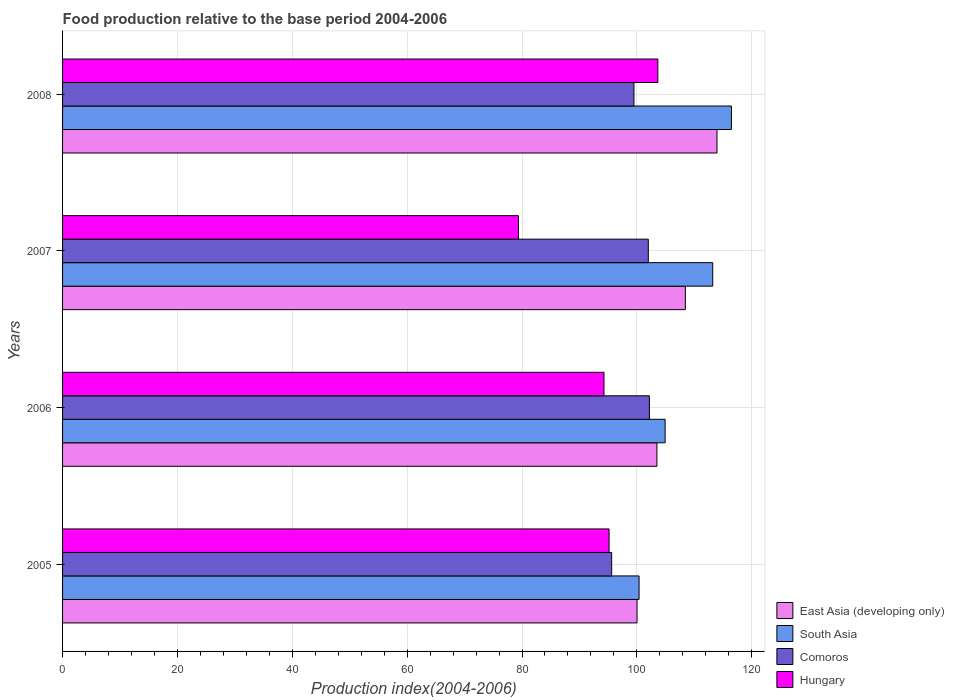How many different coloured bars are there?
Your response must be concise. 4. How many groups of bars are there?
Your response must be concise. 4. Are the number of bars on each tick of the Y-axis equal?
Ensure brevity in your answer.  Yes. How many bars are there on the 4th tick from the top?
Keep it short and to the point. 4. How many bars are there on the 4th tick from the bottom?
Your answer should be compact. 4. What is the food production index in Comoros in 2007?
Your response must be concise. 101.99. Across all years, what is the maximum food production index in East Asia (developing only)?
Offer a terse response. 113.95. Across all years, what is the minimum food production index in East Asia (developing only)?
Your answer should be very brief. 100.03. In which year was the food production index in South Asia maximum?
Ensure brevity in your answer.  2008. In which year was the food production index in Comoros minimum?
Offer a very short reply. 2005. What is the total food production index in South Asia in the graph?
Keep it short and to the point. 434.97. What is the difference between the food production index in Hungary in 2007 and that in 2008?
Ensure brevity in your answer.  -24.27. What is the difference between the food production index in Hungary in 2006 and the food production index in East Asia (developing only) in 2008?
Your response must be concise. -19.68. What is the average food production index in South Asia per year?
Offer a terse response. 108.74. In the year 2006, what is the difference between the food production index in Hungary and food production index in East Asia (developing only)?
Offer a terse response. -9.22. What is the ratio of the food production index in South Asia in 2006 to that in 2008?
Give a very brief answer. 0.9. What is the difference between the highest and the second highest food production index in Hungary?
Ensure brevity in your answer.  8.49. What is the difference between the highest and the lowest food production index in Comoros?
Provide a succinct answer. 6.57. What does the 1st bar from the top in 2008 represents?
Offer a terse response. Hungary. What does the 4th bar from the bottom in 2005 represents?
Offer a terse response. Hungary. What is the difference between two consecutive major ticks on the X-axis?
Your answer should be very brief. 20. Are the values on the major ticks of X-axis written in scientific E-notation?
Offer a very short reply. No. Does the graph contain any zero values?
Offer a very short reply. No. Does the graph contain grids?
Keep it short and to the point. Yes. Where does the legend appear in the graph?
Your answer should be very brief. Bottom right. What is the title of the graph?
Give a very brief answer. Food production relative to the base period 2004-2006. What is the label or title of the X-axis?
Make the answer very short. Production index(2004-2006). What is the Production index(2004-2006) in East Asia (developing only) in 2005?
Provide a succinct answer. 100.03. What is the Production index(2004-2006) of South Asia in 2005?
Make the answer very short. 100.38. What is the Production index(2004-2006) in Comoros in 2005?
Give a very brief answer. 95.61. What is the Production index(2004-2006) in Hungary in 2005?
Provide a succinct answer. 95.16. What is the Production index(2004-2006) in East Asia (developing only) in 2006?
Your answer should be compact. 103.49. What is the Production index(2004-2006) of South Asia in 2006?
Provide a short and direct response. 104.92. What is the Production index(2004-2006) of Comoros in 2006?
Offer a very short reply. 102.18. What is the Production index(2004-2006) of Hungary in 2006?
Provide a short and direct response. 94.27. What is the Production index(2004-2006) of East Asia (developing only) in 2007?
Keep it short and to the point. 108.44. What is the Production index(2004-2006) of South Asia in 2007?
Your answer should be very brief. 113.21. What is the Production index(2004-2006) of Comoros in 2007?
Provide a succinct answer. 101.99. What is the Production index(2004-2006) in Hungary in 2007?
Your answer should be compact. 79.38. What is the Production index(2004-2006) in East Asia (developing only) in 2008?
Keep it short and to the point. 113.95. What is the Production index(2004-2006) of South Asia in 2008?
Offer a terse response. 116.46. What is the Production index(2004-2006) of Comoros in 2008?
Your answer should be very brief. 99.49. What is the Production index(2004-2006) in Hungary in 2008?
Ensure brevity in your answer.  103.65. Across all years, what is the maximum Production index(2004-2006) of East Asia (developing only)?
Offer a very short reply. 113.95. Across all years, what is the maximum Production index(2004-2006) of South Asia?
Your response must be concise. 116.46. Across all years, what is the maximum Production index(2004-2006) of Comoros?
Offer a very short reply. 102.18. Across all years, what is the maximum Production index(2004-2006) in Hungary?
Give a very brief answer. 103.65. Across all years, what is the minimum Production index(2004-2006) of East Asia (developing only)?
Offer a terse response. 100.03. Across all years, what is the minimum Production index(2004-2006) of South Asia?
Offer a very short reply. 100.38. Across all years, what is the minimum Production index(2004-2006) in Comoros?
Make the answer very short. 95.61. Across all years, what is the minimum Production index(2004-2006) in Hungary?
Make the answer very short. 79.38. What is the total Production index(2004-2006) in East Asia (developing only) in the graph?
Your answer should be compact. 425.9. What is the total Production index(2004-2006) in South Asia in the graph?
Provide a short and direct response. 434.97. What is the total Production index(2004-2006) of Comoros in the graph?
Ensure brevity in your answer.  399.27. What is the total Production index(2004-2006) of Hungary in the graph?
Your answer should be very brief. 372.46. What is the difference between the Production index(2004-2006) in East Asia (developing only) in 2005 and that in 2006?
Your response must be concise. -3.46. What is the difference between the Production index(2004-2006) of South Asia in 2005 and that in 2006?
Ensure brevity in your answer.  -4.53. What is the difference between the Production index(2004-2006) of Comoros in 2005 and that in 2006?
Provide a succinct answer. -6.57. What is the difference between the Production index(2004-2006) of Hungary in 2005 and that in 2006?
Your response must be concise. 0.89. What is the difference between the Production index(2004-2006) of East Asia (developing only) in 2005 and that in 2007?
Provide a succinct answer. -8.41. What is the difference between the Production index(2004-2006) of South Asia in 2005 and that in 2007?
Provide a succinct answer. -12.82. What is the difference between the Production index(2004-2006) of Comoros in 2005 and that in 2007?
Your answer should be very brief. -6.38. What is the difference between the Production index(2004-2006) of Hungary in 2005 and that in 2007?
Your answer should be compact. 15.78. What is the difference between the Production index(2004-2006) in East Asia (developing only) in 2005 and that in 2008?
Provide a short and direct response. -13.92. What is the difference between the Production index(2004-2006) in South Asia in 2005 and that in 2008?
Provide a short and direct response. -16.08. What is the difference between the Production index(2004-2006) of Comoros in 2005 and that in 2008?
Offer a very short reply. -3.88. What is the difference between the Production index(2004-2006) in Hungary in 2005 and that in 2008?
Your answer should be very brief. -8.49. What is the difference between the Production index(2004-2006) in East Asia (developing only) in 2006 and that in 2007?
Offer a terse response. -4.95. What is the difference between the Production index(2004-2006) of South Asia in 2006 and that in 2007?
Provide a succinct answer. -8.29. What is the difference between the Production index(2004-2006) of Comoros in 2006 and that in 2007?
Offer a very short reply. 0.19. What is the difference between the Production index(2004-2006) in Hungary in 2006 and that in 2007?
Ensure brevity in your answer.  14.89. What is the difference between the Production index(2004-2006) in East Asia (developing only) in 2006 and that in 2008?
Offer a very short reply. -10.46. What is the difference between the Production index(2004-2006) of South Asia in 2006 and that in 2008?
Give a very brief answer. -11.54. What is the difference between the Production index(2004-2006) of Comoros in 2006 and that in 2008?
Your response must be concise. 2.69. What is the difference between the Production index(2004-2006) of Hungary in 2006 and that in 2008?
Your answer should be compact. -9.38. What is the difference between the Production index(2004-2006) in East Asia (developing only) in 2007 and that in 2008?
Your response must be concise. -5.51. What is the difference between the Production index(2004-2006) of South Asia in 2007 and that in 2008?
Offer a terse response. -3.25. What is the difference between the Production index(2004-2006) in Hungary in 2007 and that in 2008?
Give a very brief answer. -24.27. What is the difference between the Production index(2004-2006) of East Asia (developing only) in 2005 and the Production index(2004-2006) of South Asia in 2006?
Ensure brevity in your answer.  -4.89. What is the difference between the Production index(2004-2006) of East Asia (developing only) in 2005 and the Production index(2004-2006) of Comoros in 2006?
Make the answer very short. -2.15. What is the difference between the Production index(2004-2006) of East Asia (developing only) in 2005 and the Production index(2004-2006) of Hungary in 2006?
Your answer should be very brief. 5.76. What is the difference between the Production index(2004-2006) in South Asia in 2005 and the Production index(2004-2006) in Comoros in 2006?
Your answer should be very brief. -1.8. What is the difference between the Production index(2004-2006) of South Asia in 2005 and the Production index(2004-2006) of Hungary in 2006?
Give a very brief answer. 6.11. What is the difference between the Production index(2004-2006) in Comoros in 2005 and the Production index(2004-2006) in Hungary in 2006?
Provide a succinct answer. 1.34. What is the difference between the Production index(2004-2006) in East Asia (developing only) in 2005 and the Production index(2004-2006) in South Asia in 2007?
Offer a very short reply. -13.18. What is the difference between the Production index(2004-2006) in East Asia (developing only) in 2005 and the Production index(2004-2006) in Comoros in 2007?
Offer a very short reply. -1.96. What is the difference between the Production index(2004-2006) of East Asia (developing only) in 2005 and the Production index(2004-2006) of Hungary in 2007?
Provide a succinct answer. 20.65. What is the difference between the Production index(2004-2006) of South Asia in 2005 and the Production index(2004-2006) of Comoros in 2007?
Your answer should be very brief. -1.61. What is the difference between the Production index(2004-2006) in South Asia in 2005 and the Production index(2004-2006) in Hungary in 2007?
Offer a very short reply. 21. What is the difference between the Production index(2004-2006) in Comoros in 2005 and the Production index(2004-2006) in Hungary in 2007?
Provide a succinct answer. 16.23. What is the difference between the Production index(2004-2006) in East Asia (developing only) in 2005 and the Production index(2004-2006) in South Asia in 2008?
Your answer should be very brief. -16.44. What is the difference between the Production index(2004-2006) of East Asia (developing only) in 2005 and the Production index(2004-2006) of Comoros in 2008?
Provide a short and direct response. 0.54. What is the difference between the Production index(2004-2006) of East Asia (developing only) in 2005 and the Production index(2004-2006) of Hungary in 2008?
Provide a succinct answer. -3.62. What is the difference between the Production index(2004-2006) in South Asia in 2005 and the Production index(2004-2006) in Comoros in 2008?
Offer a terse response. 0.89. What is the difference between the Production index(2004-2006) of South Asia in 2005 and the Production index(2004-2006) of Hungary in 2008?
Give a very brief answer. -3.27. What is the difference between the Production index(2004-2006) of Comoros in 2005 and the Production index(2004-2006) of Hungary in 2008?
Keep it short and to the point. -8.04. What is the difference between the Production index(2004-2006) in East Asia (developing only) in 2006 and the Production index(2004-2006) in South Asia in 2007?
Your answer should be very brief. -9.72. What is the difference between the Production index(2004-2006) in East Asia (developing only) in 2006 and the Production index(2004-2006) in Comoros in 2007?
Offer a terse response. 1.5. What is the difference between the Production index(2004-2006) of East Asia (developing only) in 2006 and the Production index(2004-2006) of Hungary in 2007?
Your answer should be compact. 24.11. What is the difference between the Production index(2004-2006) of South Asia in 2006 and the Production index(2004-2006) of Comoros in 2007?
Offer a terse response. 2.93. What is the difference between the Production index(2004-2006) in South Asia in 2006 and the Production index(2004-2006) in Hungary in 2007?
Give a very brief answer. 25.54. What is the difference between the Production index(2004-2006) in Comoros in 2006 and the Production index(2004-2006) in Hungary in 2007?
Keep it short and to the point. 22.8. What is the difference between the Production index(2004-2006) in East Asia (developing only) in 2006 and the Production index(2004-2006) in South Asia in 2008?
Offer a terse response. -12.98. What is the difference between the Production index(2004-2006) of East Asia (developing only) in 2006 and the Production index(2004-2006) of Comoros in 2008?
Ensure brevity in your answer.  4. What is the difference between the Production index(2004-2006) of East Asia (developing only) in 2006 and the Production index(2004-2006) of Hungary in 2008?
Your answer should be very brief. -0.16. What is the difference between the Production index(2004-2006) in South Asia in 2006 and the Production index(2004-2006) in Comoros in 2008?
Your response must be concise. 5.43. What is the difference between the Production index(2004-2006) in South Asia in 2006 and the Production index(2004-2006) in Hungary in 2008?
Your answer should be very brief. 1.27. What is the difference between the Production index(2004-2006) of Comoros in 2006 and the Production index(2004-2006) of Hungary in 2008?
Offer a very short reply. -1.47. What is the difference between the Production index(2004-2006) of East Asia (developing only) in 2007 and the Production index(2004-2006) of South Asia in 2008?
Keep it short and to the point. -8.02. What is the difference between the Production index(2004-2006) of East Asia (developing only) in 2007 and the Production index(2004-2006) of Comoros in 2008?
Provide a succinct answer. 8.95. What is the difference between the Production index(2004-2006) in East Asia (developing only) in 2007 and the Production index(2004-2006) in Hungary in 2008?
Ensure brevity in your answer.  4.79. What is the difference between the Production index(2004-2006) of South Asia in 2007 and the Production index(2004-2006) of Comoros in 2008?
Your response must be concise. 13.72. What is the difference between the Production index(2004-2006) in South Asia in 2007 and the Production index(2004-2006) in Hungary in 2008?
Offer a terse response. 9.56. What is the difference between the Production index(2004-2006) in Comoros in 2007 and the Production index(2004-2006) in Hungary in 2008?
Make the answer very short. -1.66. What is the average Production index(2004-2006) in East Asia (developing only) per year?
Your answer should be compact. 106.47. What is the average Production index(2004-2006) of South Asia per year?
Offer a terse response. 108.74. What is the average Production index(2004-2006) in Comoros per year?
Ensure brevity in your answer.  99.82. What is the average Production index(2004-2006) of Hungary per year?
Provide a short and direct response. 93.11. In the year 2005, what is the difference between the Production index(2004-2006) in East Asia (developing only) and Production index(2004-2006) in South Asia?
Your answer should be compact. -0.36. In the year 2005, what is the difference between the Production index(2004-2006) of East Asia (developing only) and Production index(2004-2006) of Comoros?
Keep it short and to the point. 4.42. In the year 2005, what is the difference between the Production index(2004-2006) in East Asia (developing only) and Production index(2004-2006) in Hungary?
Your answer should be compact. 4.87. In the year 2005, what is the difference between the Production index(2004-2006) of South Asia and Production index(2004-2006) of Comoros?
Offer a very short reply. 4.77. In the year 2005, what is the difference between the Production index(2004-2006) in South Asia and Production index(2004-2006) in Hungary?
Provide a short and direct response. 5.22. In the year 2005, what is the difference between the Production index(2004-2006) in Comoros and Production index(2004-2006) in Hungary?
Give a very brief answer. 0.45. In the year 2006, what is the difference between the Production index(2004-2006) in East Asia (developing only) and Production index(2004-2006) in South Asia?
Make the answer very short. -1.43. In the year 2006, what is the difference between the Production index(2004-2006) of East Asia (developing only) and Production index(2004-2006) of Comoros?
Make the answer very short. 1.31. In the year 2006, what is the difference between the Production index(2004-2006) in East Asia (developing only) and Production index(2004-2006) in Hungary?
Provide a short and direct response. 9.22. In the year 2006, what is the difference between the Production index(2004-2006) of South Asia and Production index(2004-2006) of Comoros?
Make the answer very short. 2.74. In the year 2006, what is the difference between the Production index(2004-2006) in South Asia and Production index(2004-2006) in Hungary?
Offer a very short reply. 10.65. In the year 2006, what is the difference between the Production index(2004-2006) in Comoros and Production index(2004-2006) in Hungary?
Your response must be concise. 7.91. In the year 2007, what is the difference between the Production index(2004-2006) in East Asia (developing only) and Production index(2004-2006) in South Asia?
Make the answer very short. -4.77. In the year 2007, what is the difference between the Production index(2004-2006) in East Asia (developing only) and Production index(2004-2006) in Comoros?
Make the answer very short. 6.45. In the year 2007, what is the difference between the Production index(2004-2006) in East Asia (developing only) and Production index(2004-2006) in Hungary?
Make the answer very short. 29.06. In the year 2007, what is the difference between the Production index(2004-2006) of South Asia and Production index(2004-2006) of Comoros?
Make the answer very short. 11.22. In the year 2007, what is the difference between the Production index(2004-2006) in South Asia and Production index(2004-2006) in Hungary?
Your response must be concise. 33.83. In the year 2007, what is the difference between the Production index(2004-2006) of Comoros and Production index(2004-2006) of Hungary?
Provide a succinct answer. 22.61. In the year 2008, what is the difference between the Production index(2004-2006) in East Asia (developing only) and Production index(2004-2006) in South Asia?
Your answer should be very brief. -2.52. In the year 2008, what is the difference between the Production index(2004-2006) in East Asia (developing only) and Production index(2004-2006) in Comoros?
Give a very brief answer. 14.46. In the year 2008, what is the difference between the Production index(2004-2006) in East Asia (developing only) and Production index(2004-2006) in Hungary?
Ensure brevity in your answer.  10.3. In the year 2008, what is the difference between the Production index(2004-2006) in South Asia and Production index(2004-2006) in Comoros?
Make the answer very short. 16.97. In the year 2008, what is the difference between the Production index(2004-2006) of South Asia and Production index(2004-2006) of Hungary?
Offer a very short reply. 12.81. In the year 2008, what is the difference between the Production index(2004-2006) of Comoros and Production index(2004-2006) of Hungary?
Give a very brief answer. -4.16. What is the ratio of the Production index(2004-2006) of East Asia (developing only) in 2005 to that in 2006?
Ensure brevity in your answer.  0.97. What is the ratio of the Production index(2004-2006) of South Asia in 2005 to that in 2006?
Offer a very short reply. 0.96. What is the ratio of the Production index(2004-2006) in Comoros in 2005 to that in 2006?
Keep it short and to the point. 0.94. What is the ratio of the Production index(2004-2006) of Hungary in 2005 to that in 2006?
Provide a short and direct response. 1.01. What is the ratio of the Production index(2004-2006) of East Asia (developing only) in 2005 to that in 2007?
Make the answer very short. 0.92. What is the ratio of the Production index(2004-2006) in South Asia in 2005 to that in 2007?
Provide a succinct answer. 0.89. What is the ratio of the Production index(2004-2006) of Comoros in 2005 to that in 2007?
Keep it short and to the point. 0.94. What is the ratio of the Production index(2004-2006) in Hungary in 2005 to that in 2007?
Your response must be concise. 1.2. What is the ratio of the Production index(2004-2006) in East Asia (developing only) in 2005 to that in 2008?
Keep it short and to the point. 0.88. What is the ratio of the Production index(2004-2006) in South Asia in 2005 to that in 2008?
Your answer should be very brief. 0.86. What is the ratio of the Production index(2004-2006) in Hungary in 2005 to that in 2008?
Make the answer very short. 0.92. What is the ratio of the Production index(2004-2006) of East Asia (developing only) in 2006 to that in 2007?
Provide a succinct answer. 0.95. What is the ratio of the Production index(2004-2006) in South Asia in 2006 to that in 2007?
Your answer should be very brief. 0.93. What is the ratio of the Production index(2004-2006) of Hungary in 2006 to that in 2007?
Ensure brevity in your answer.  1.19. What is the ratio of the Production index(2004-2006) of East Asia (developing only) in 2006 to that in 2008?
Offer a terse response. 0.91. What is the ratio of the Production index(2004-2006) in South Asia in 2006 to that in 2008?
Offer a terse response. 0.9. What is the ratio of the Production index(2004-2006) in Comoros in 2006 to that in 2008?
Offer a very short reply. 1.03. What is the ratio of the Production index(2004-2006) in Hungary in 2006 to that in 2008?
Provide a short and direct response. 0.91. What is the ratio of the Production index(2004-2006) in East Asia (developing only) in 2007 to that in 2008?
Offer a terse response. 0.95. What is the ratio of the Production index(2004-2006) in South Asia in 2007 to that in 2008?
Your response must be concise. 0.97. What is the ratio of the Production index(2004-2006) in Comoros in 2007 to that in 2008?
Make the answer very short. 1.03. What is the ratio of the Production index(2004-2006) in Hungary in 2007 to that in 2008?
Provide a short and direct response. 0.77. What is the difference between the highest and the second highest Production index(2004-2006) of East Asia (developing only)?
Keep it short and to the point. 5.51. What is the difference between the highest and the second highest Production index(2004-2006) of South Asia?
Your answer should be very brief. 3.25. What is the difference between the highest and the second highest Production index(2004-2006) in Comoros?
Keep it short and to the point. 0.19. What is the difference between the highest and the second highest Production index(2004-2006) in Hungary?
Your response must be concise. 8.49. What is the difference between the highest and the lowest Production index(2004-2006) of East Asia (developing only)?
Give a very brief answer. 13.92. What is the difference between the highest and the lowest Production index(2004-2006) in South Asia?
Provide a succinct answer. 16.08. What is the difference between the highest and the lowest Production index(2004-2006) of Comoros?
Offer a terse response. 6.57. What is the difference between the highest and the lowest Production index(2004-2006) in Hungary?
Offer a very short reply. 24.27. 